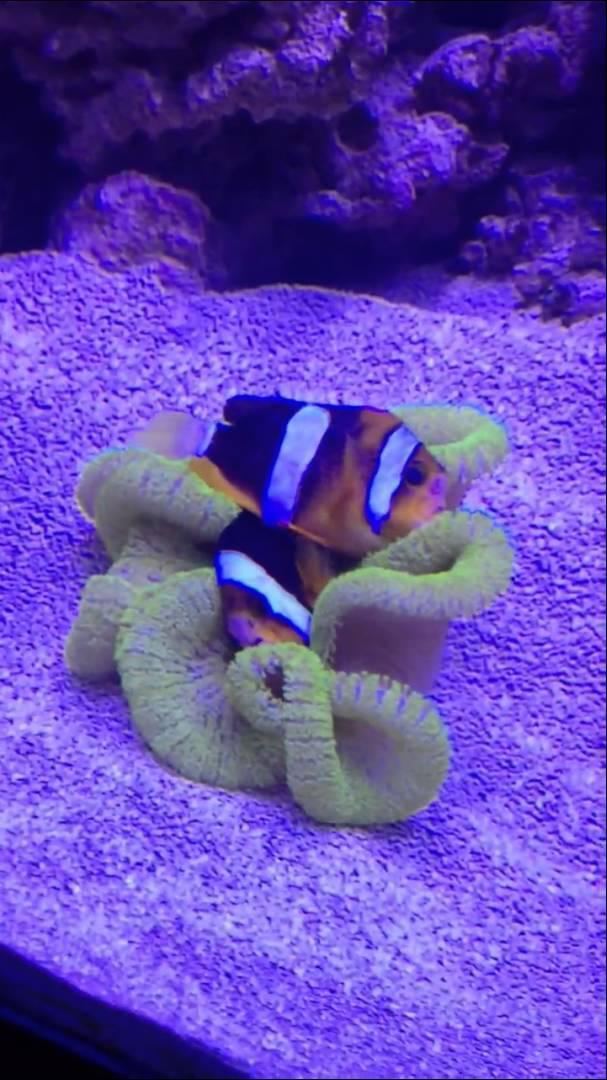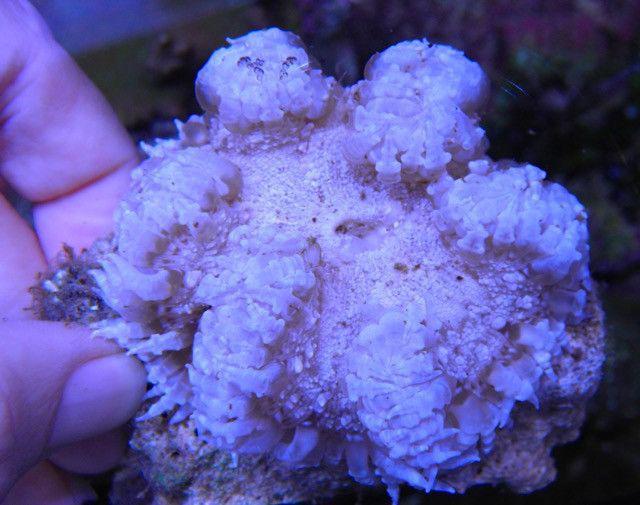The first image is the image on the left, the second image is the image on the right. Assess this claim about the two images: "Each image shows at least one clown fish swimming among anemone.". Correct or not? Answer yes or no. No. The first image is the image on the left, the second image is the image on the right. Given the left and right images, does the statement "A fish is swimming in the sea plant in both the images." hold true? Answer yes or no. No. 